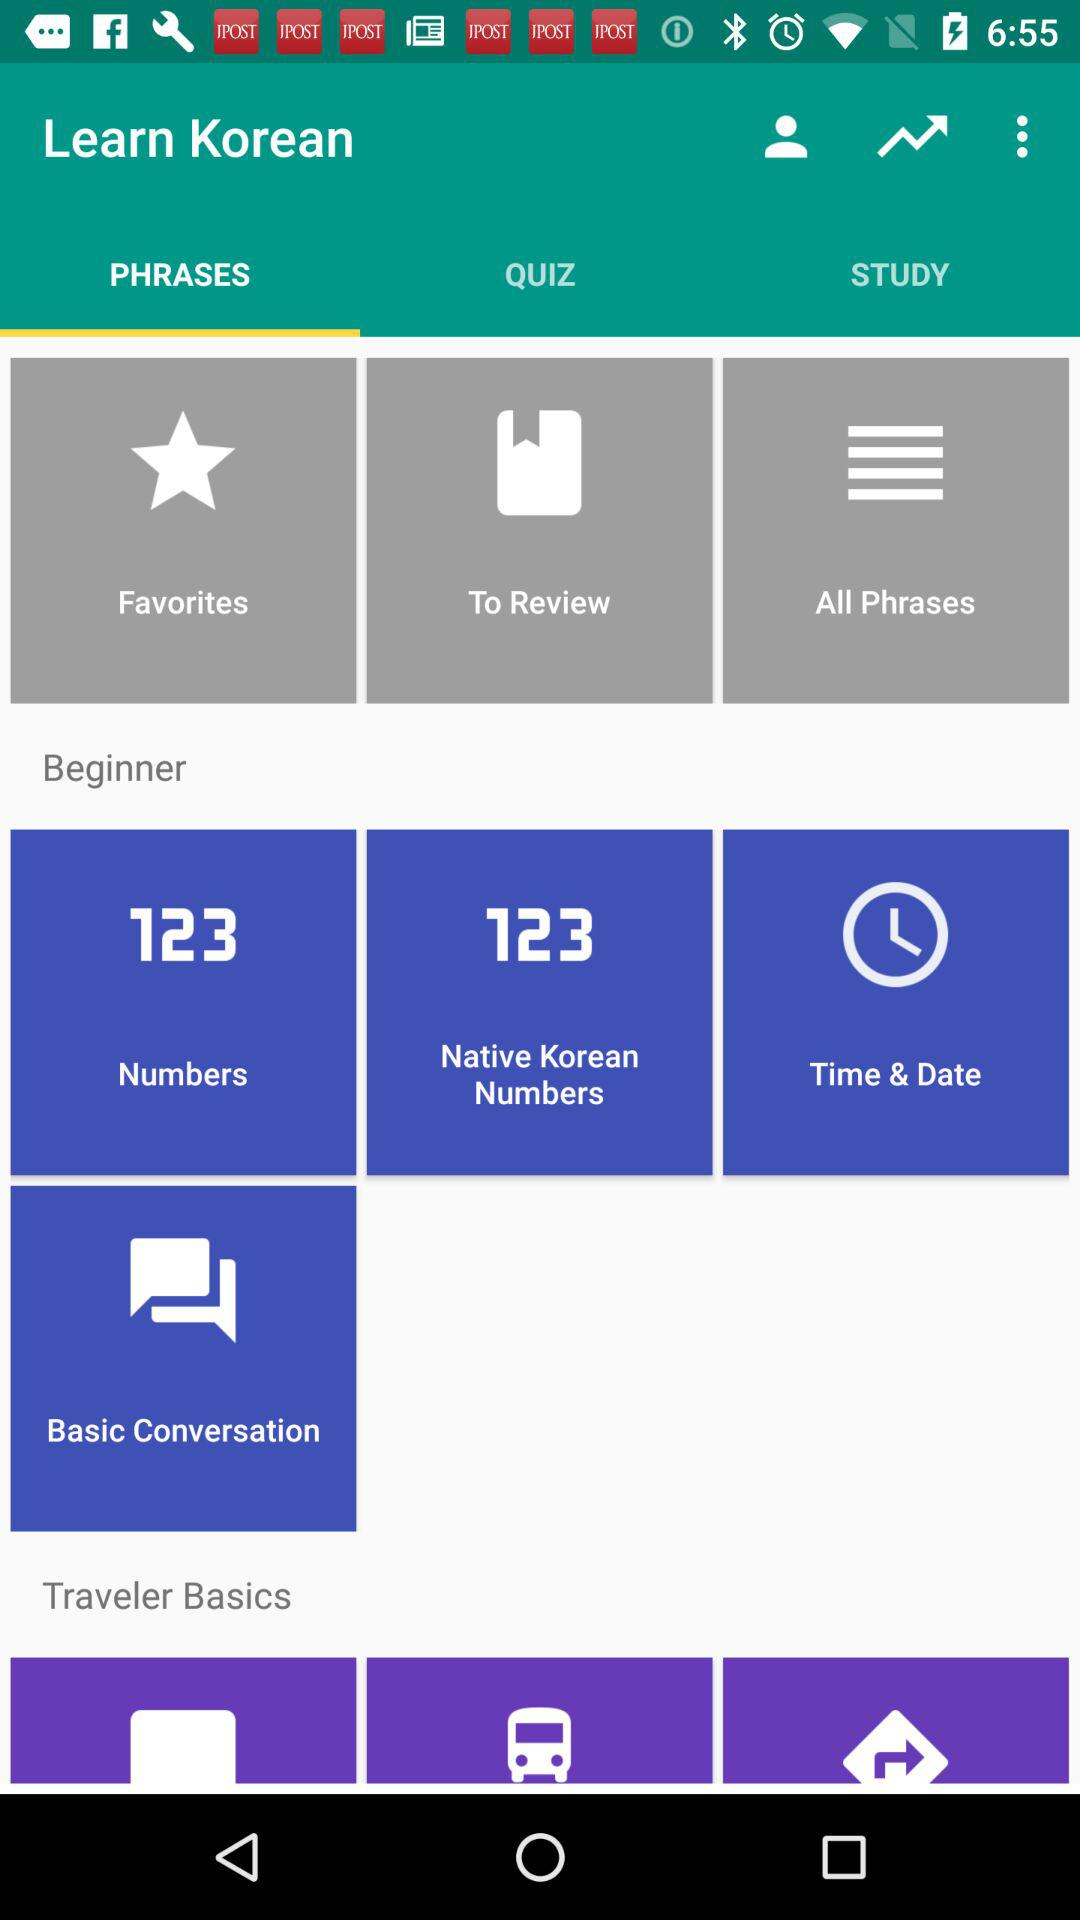Which tab is selected? The selected tab is "PHRASES". 